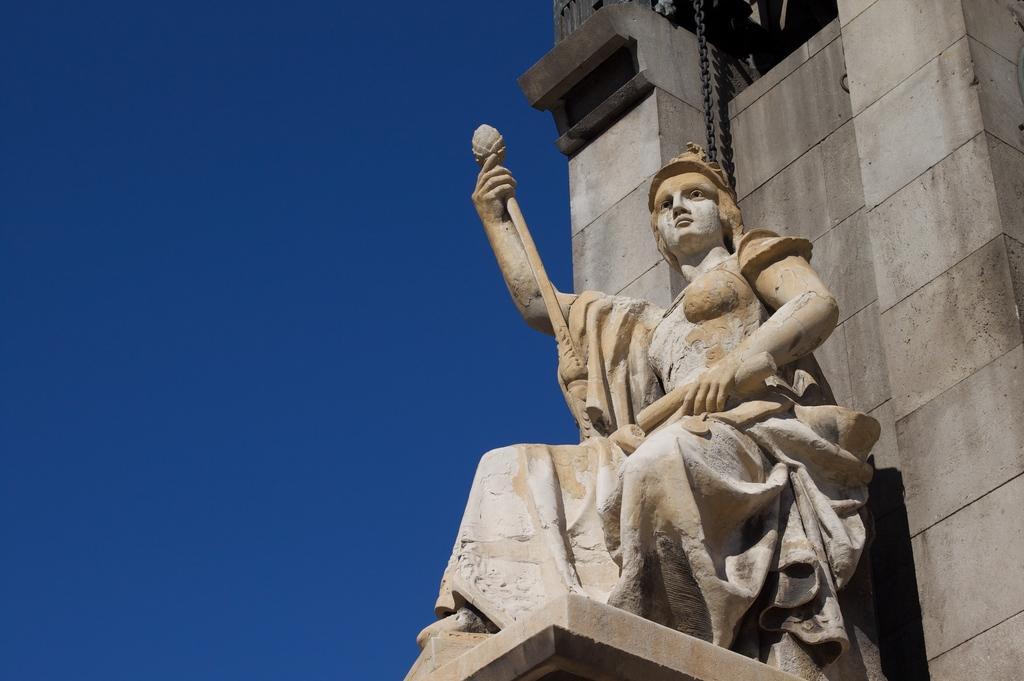In one or two sentences, can you explain what this image depicts? In this image I can see a statue, background the building is in brown and cream color and the sky is in blue color. 